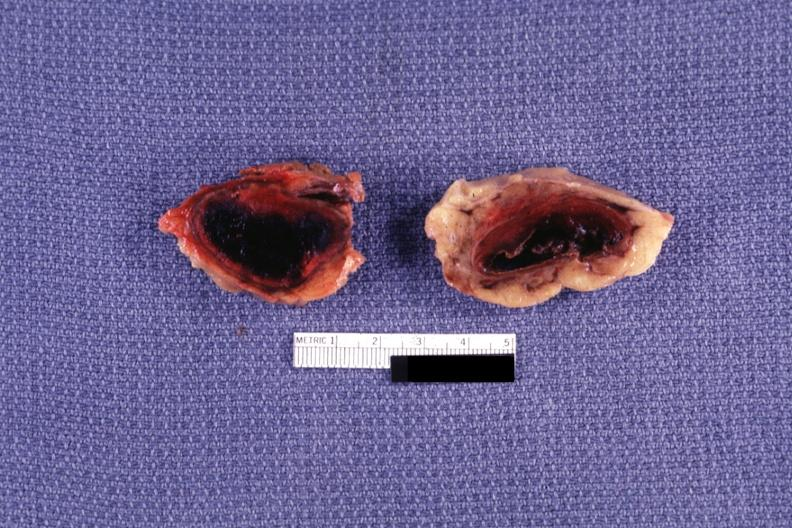where does this belong to?
Answer the question using a single word or phrase. Endocrine system 